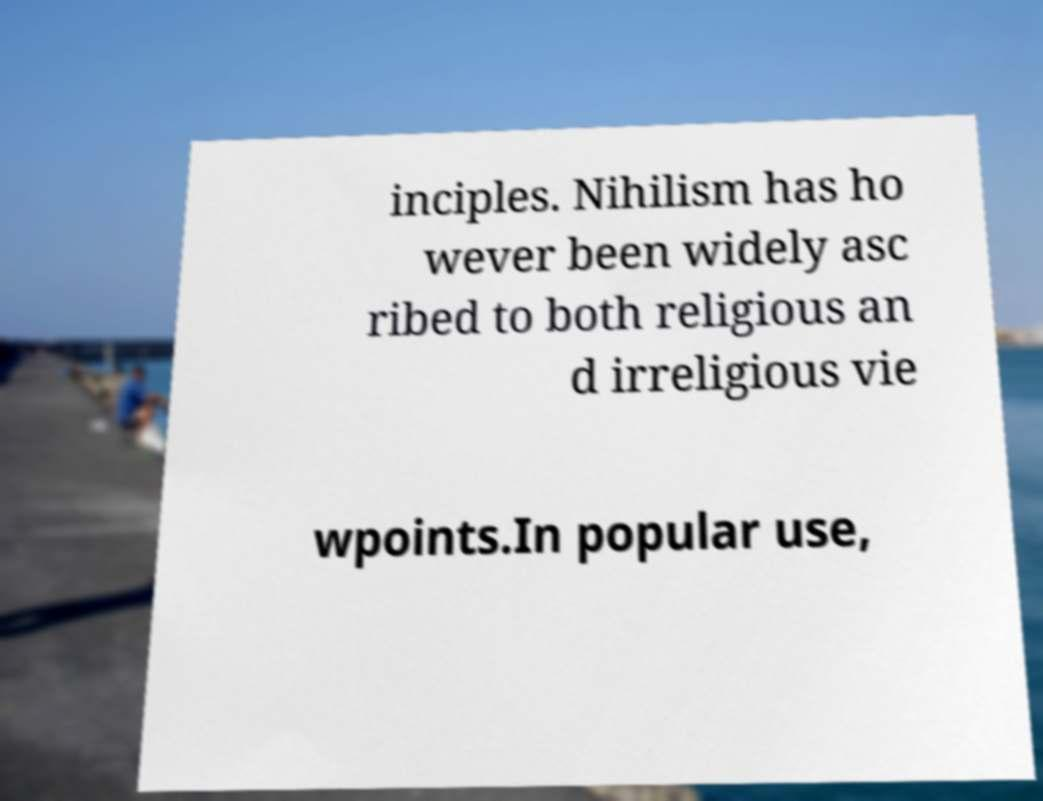Can you accurately transcribe the text from the provided image for me? inciples. Nihilism has ho wever been widely asc ribed to both religious an d irreligious vie wpoints.In popular use, 